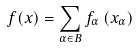Convert formula to latex. <formula><loc_0><loc_0><loc_500><loc_500>f ( x ) = \sum _ { \alpha \in B } f _ { \alpha } \left ( x _ { \alpha } \right )</formula> 